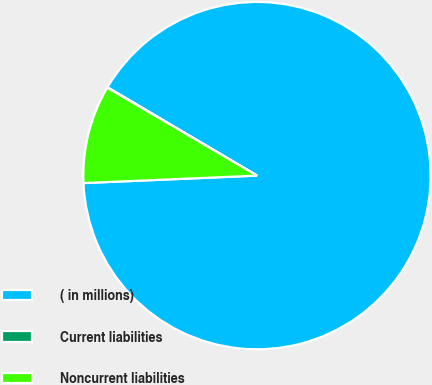Convert chart to OTSL. <chart><loc_0><loc_0><loc_500><loc_500><pie_chart><fcel>( in millions)<fcel>Current liabilities<fcel>Noncurrent liabilities<nl><fcel>90.82%<fcel>0.05%<fcel>9.13%<nl></chart> 